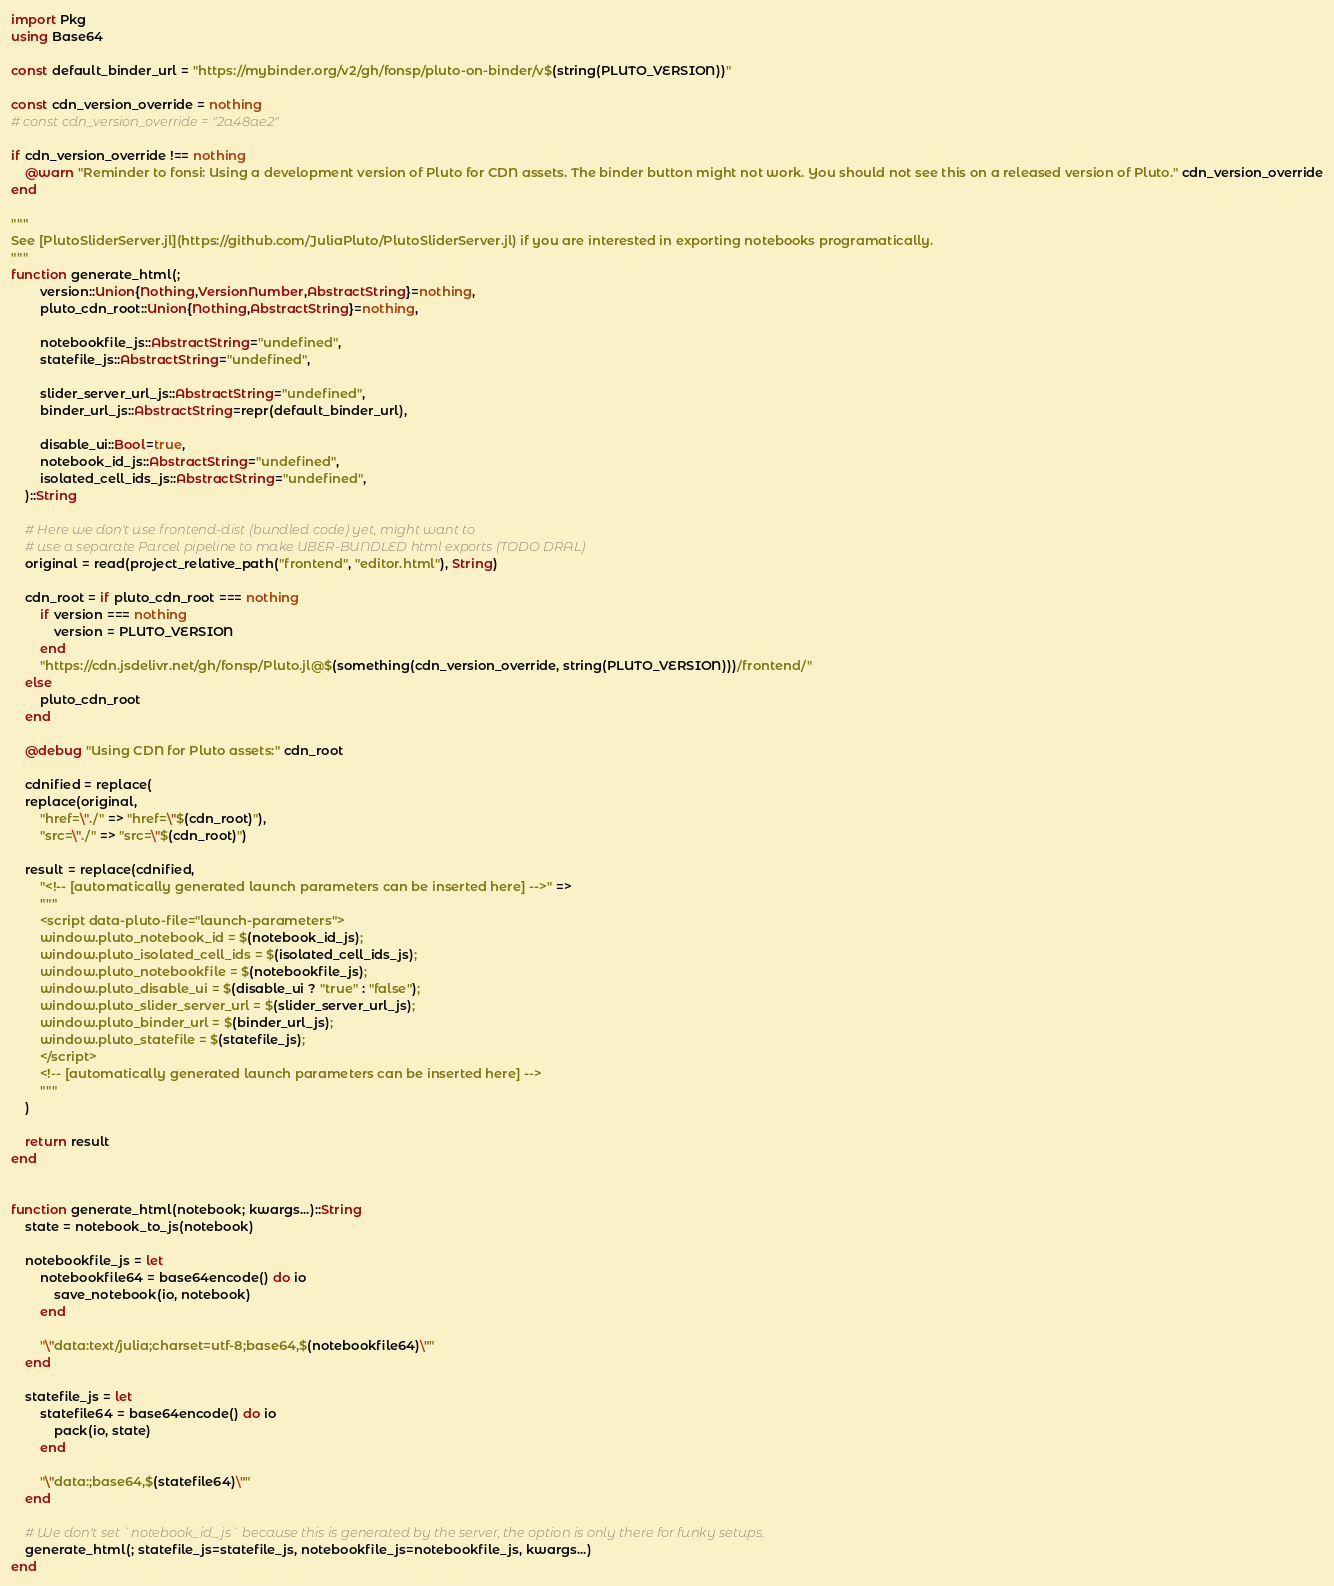<code> <loc_0><loc_0><loc_500><loc_500><_Julia_>import Pkg
using Base64

const default_binder_url = "https://mybinder.org/v2/gh/fonsp/pluto-on-binder/v$(string(PLUTO_VERSION))"

const cdn_version_override = nothing
# const cdn_version_override = "2a48ae2"

if cdn_version_override !== nothing
    @warn "Reminder to fonsi: Using a development version of Pluto for CDN assets. The binder button might not work. You should not see this on a released version of Pluto." cdn_version_override
end

"""
See [PlutoSliderServer.jl](https://github.com/JuliaPluto/PlutoSliderServer.jl) if you are interested in exporting notebooks programatically.
"""
function generate_html(;
        version::Union{Nothing,VersionNumber,AbstractString}=nothing, 
        pluto_cdn_root::Union{Nothing,AbstractString}=nothing,
        
        notebookfile_js::AbstractString="undefined", 
        statefile_js::AbstractString="undefined", 
        
        slider_server_url_js::AbstractString="undefined", 
        binder_url_js::AbstractString=repr(default_binder_url),
        
        disable_ui::Bool=true, 
        notebook_id_js::AbstractString="undefined", 
        isolated_cell_ids_js::AbstractString="undefined",
    )::String

    # Here we don't use frontend-dist (bundled code) yet, might want to
    # use a separate Parcel pipeline to make UBER-BUNDLED html exports (TODO DRAL)
    original = read(project_relative_path("frontend", "editor.html"), String)

    cdn_root = if pluto_cdn_root === nothing
        if version === nothing
            version = PLUTO_VERSION
        end
        "https://cdn.jsdelivr.net/gh/fonsp/Pluto.jl@$(something(cdn_version_override, string(PLUTO_VERSION)))/frontend/"
    else
        pluto_cdn_root
    end

    @debug "Using CDN for Pluto assets:" cdn_root

    cdnified = replace(
    replace(original, 
        "href=\"./" => "href=\"$(cdn_root)"),
        "src=\"./" => "src=\"$(cdn_root)")

    result = replace(cdnified, 
        "<!-- [automatically generated launch parameters can be inserted here] -->" => 
        """
        <script data-pluto-file="launch-parameters">
        window.pluto_notebook_id = $(notebook_id_js);
        window.pluto_isolated_cell_ids = $(isolated_cell_ids_js);
        window.pluto_notebookfile = $(notebookfile_js);
        window.pluto_disable_ui = $(disable_ui ? "true" : "false");
        window.pluto_slider_server_url = $(slider_server_url_js);
        window.pluto_binder_url = $(binder_url_js);
        window.pluto_statefile = $(statefile_js);
        </script>
        <!-- [automatically generated launch parameters can be inserted here] -->
        """
    )

    return result
end


function generate_html(notebook; kwargs...)::String
    state = notebook_to_js(notebook)

    notebookfile_js = let
        notebookfile64 = base64encode() do io
            save_notebook(io, notebook)
        end

        "\"data:text/julia;charset=utf-8;base64,$(notebookfile64)\""
    end

    statefile_js = let
        statefile64 = base64encode() do io
            pack(io, state)
        end

        "\"data:;base64,$(statefile64)\""
    end
    
    # We don't set `notebook_id_js` because this is generated by the server, the option is only there for funky setups.
    generate_html(; statefile_js=statefile_js, notebookfile_js=notebookfile_js, kwargs...)
end
</code> 